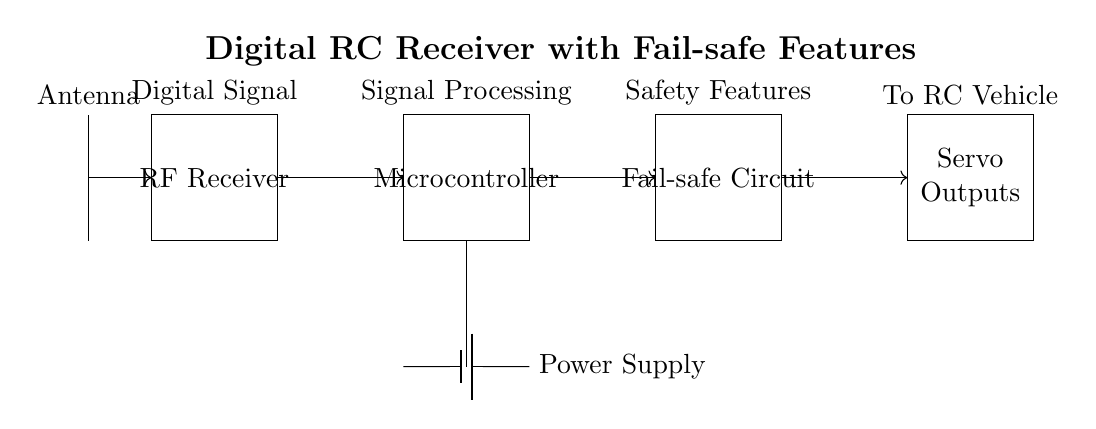What is the purpose of the RF receiver? The RF receiver is responsible for receiving radio frequency signals, which are digitally encoded commands from the transmitter. This is a crucial step for the control and operation of the RC vehicle.
Answer: Receiving radio frequency signals What component follows the RF receiver? The component that follows the RF receiver in the diagram is the microcontroller, which processes the received signals and sends commands to the fail-safe circuit.
Answer: Microcontroller How many servo outputs are there? There are four labeled servo outputs shown in the circuit, which control various servos based on the processed signals from the microcontroller.
Answer: Four What does the fail-safe circuit ensure? The fail-safe circuit ensures that the RC vehicle will take a predefined action, such as stopping or returning to a safe state, in case of signal loss from the transmitter to prevent runaway situations.
Answer: Safety action in signal loss What type of circuit is this? This is a digital radio control receiver circuit designed specifically for RC vehicles, featuring fail-safe mechanisms to enhance operational safety and responsiveness.
Answer: Digital RC receiver circuit What is the role of the power supply in the circuit? The power supply provides the necessary voltage and current to all components in the circuit, including the RF receiver, microcontroller, and fail-safe circuit, ensuring proper functionality.
Answer: Powers all components What type of signal does the antenna receive? The antenna receives radio frequency signals, which are used for communication between the transmitter and the RC vehicle’s receiver system.
Answer: Radio frequency signals 